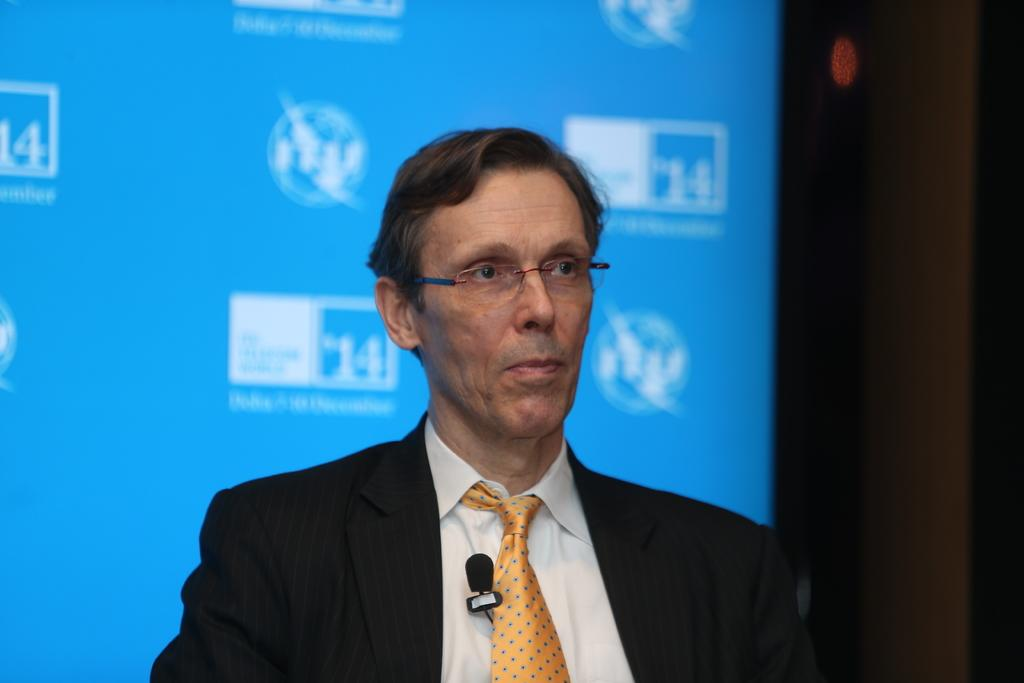Who is present in the image? There is a man in the image. What is the man wearing? The man is wearing a suit and spectacles. What can be seen in the background of the image? There is a screen in the background of the image. How many cats are sitting on the man's lap in the image? There are no cats present in the image. What type of government is depicted in the image? The image does not depict any government or political entity. 